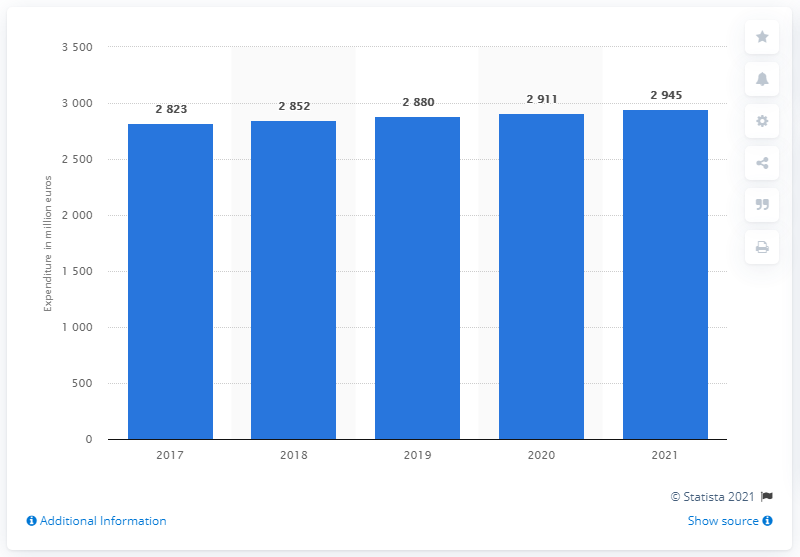Specify some key components in this picture. It is projected that the B2B industry will spend a significant amount in 2021. 